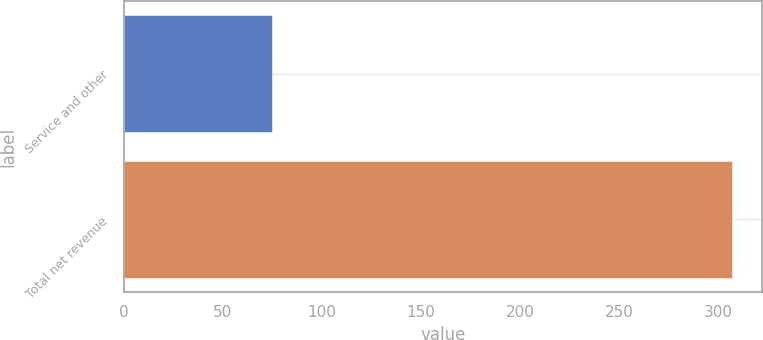<chart> <loc_0><loc_0><loc_500><loc_500><bar_chart><fcel>Service and other<fcel>Total net revenue<nl><fcel>75<fcel>307<nl></chart> 